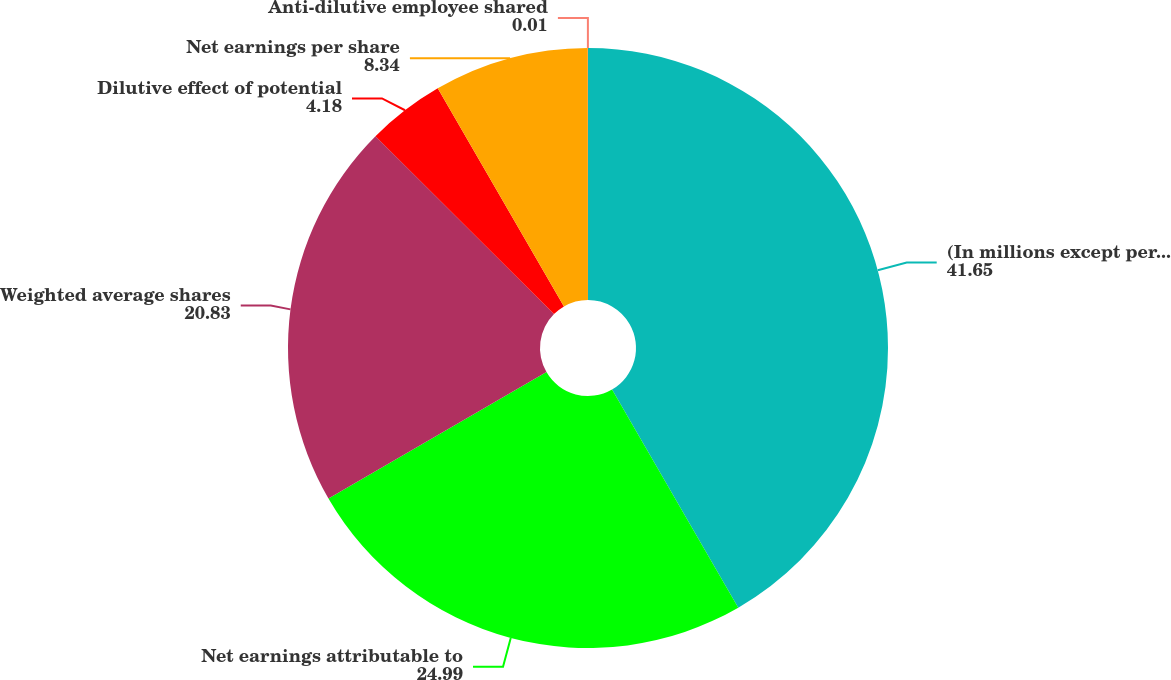Convert chart to OTSL. <chart><loc_0><loc_0><loc_500><loc_500><pie_chart><fcel>(In millions except per share<fcel>Net earnings attributable to<fcel>Weighted average shares<fcel>Dilutive effect of potential<fcel>Net earnings per share<fcel>Anti-dilutive employee shared<nl><fcel>41.65%<fcel>24.99%<fcel>20.83%<fcel>4.18%<fcel>8.34%<fcel>0.01%<nl></chart> 